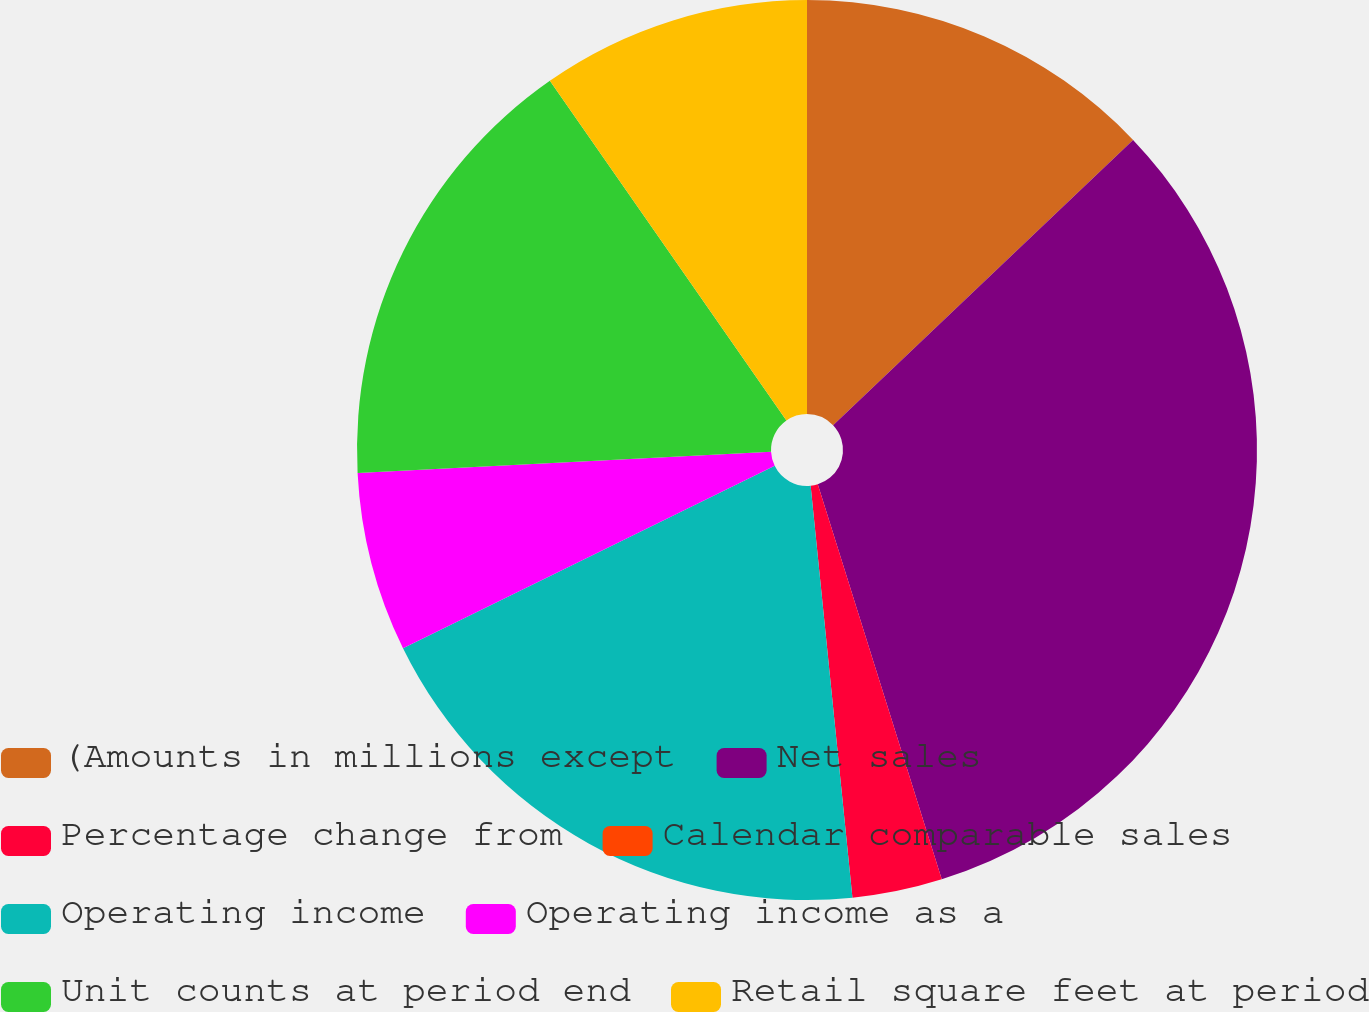Convert chart. <chart><loc_0><loc_0><loc_500><loc_500><pie_chart><fcel>(Amounts in millions except<fcel>Net sales<fcel>Percentage change from<fcel>Calendar comparable sales<fcel>Operating income<fcel>Operating income as a<fcel>Unit counts at period end<fcel>Retail square feet at period<nl><fcel>12.9%<fcel>32.26%<fcel>3.23%<fcel>0.0%<fcel>19.35%<fcel>6.45%<fcel>16.13%<fcel>9.68%<nl></chart> 